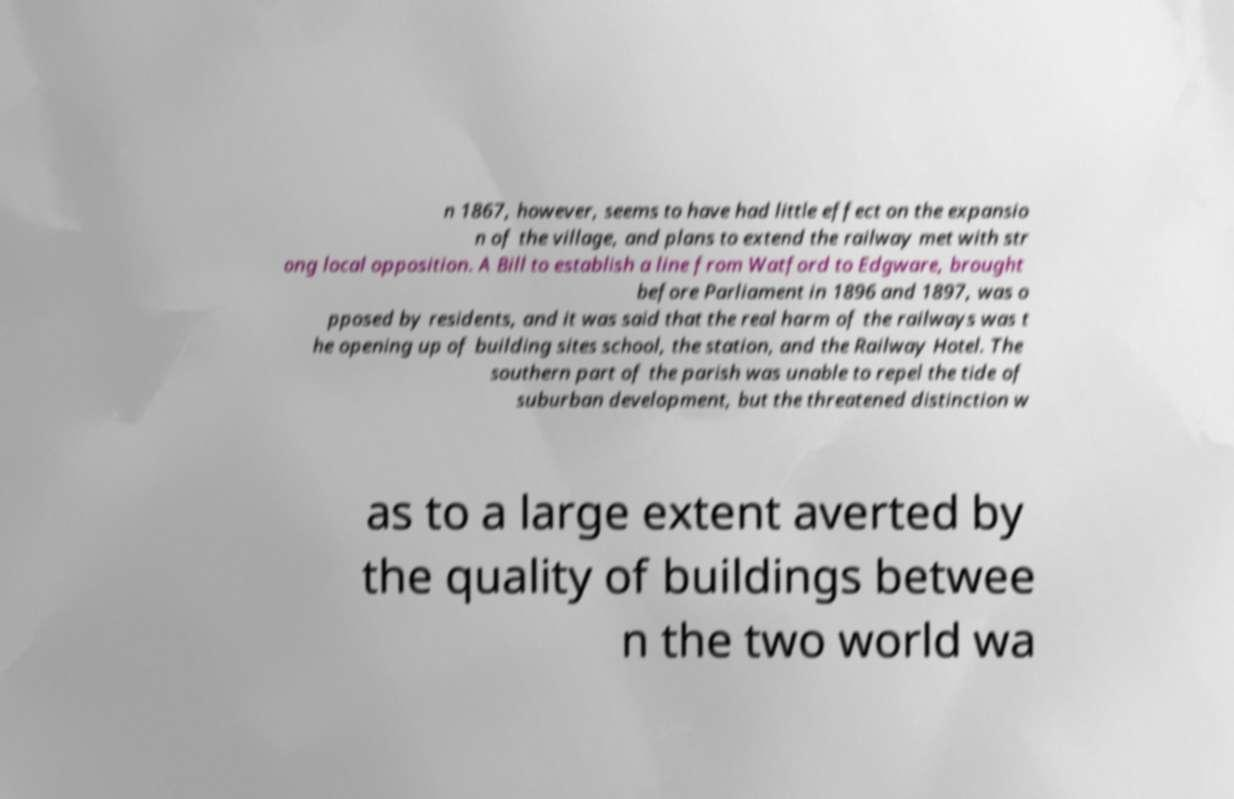Please read and relay the text visible in this image. What does it say? n 1867, however, seems to have had little effect on the expansio n of the village, and plans to extend the railway met with str ong local opposition. A Bill to establish a line from Watford to Edgware, brought before Parliament in 1896 and 1897, was o pposed by residents, and it was said that the real harm of the railways was t he opening up of building sites school, the station, and the Railway Hotel. The southern part of the parish was unable to repel the tide of suburban development, but the threatened distinction w as to a large extent averted by the quality of buildings betwee n the two world wa 